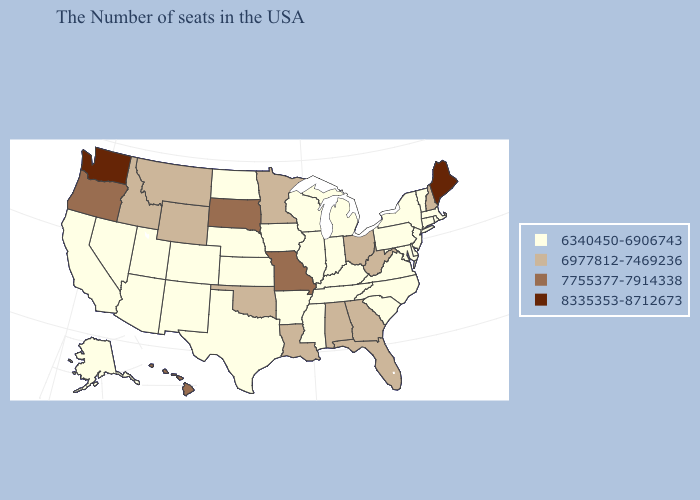Does Maine have the highest value in the USA?
Be succinct. Yes. What is the lowest value in states that border Utah?
Concise answer only. 6340450-6906743. Name the states that have a value in the range 8335353-8712673?
Answer briefly. Maine, Washington. What is the lowest value in the USA?
Be succinct. 6340450-6906743. Does Pennsylvania have a higher value than Arizona?
Answer briefly. No. What is the value of California?
Concise answer only. 6340450-6906743. Does Nevada have the lowest value in the West?
Be succinct. Yes. How many symbols are there in the legend?
Short answer required. 4. What is the value of Alaska?
Be succinct. 6340450-6906743. Name the states that have a value in the range 6977812-7469236?
Answer briefly. New Hampshire, West Virginia, Ohio, Florida, Georgia, Alabama, Louisiana, Minnesota, Oklahoma, Wyoming, Montana, Idaho. Name the states that have a value in the range 6977812-7469236?
Answer briefly. New Hampshire, West Virginia, Ohio, Florida, Georgia, Alabama, Louisiana, Minnesota, Oklahoma, Wyoming, Montana, Idaho. Does Nebraska have a higher value than South Carolina?
Keep it brief. No. Name the states that have a value in the range 6977812-7469236?
Concise answer only. New Hampshire, West Virginia, Ohio, Florida, Georgia, Alabama, Louisiana, Minnesota, Oklahoma, Wyoming, Montana, Idaho. How many symbols are there in the legend?
Keep it brief. 4. Among the states that border Idaho , which have the lowest value?
Keep it brief. Utah, Nevada. 